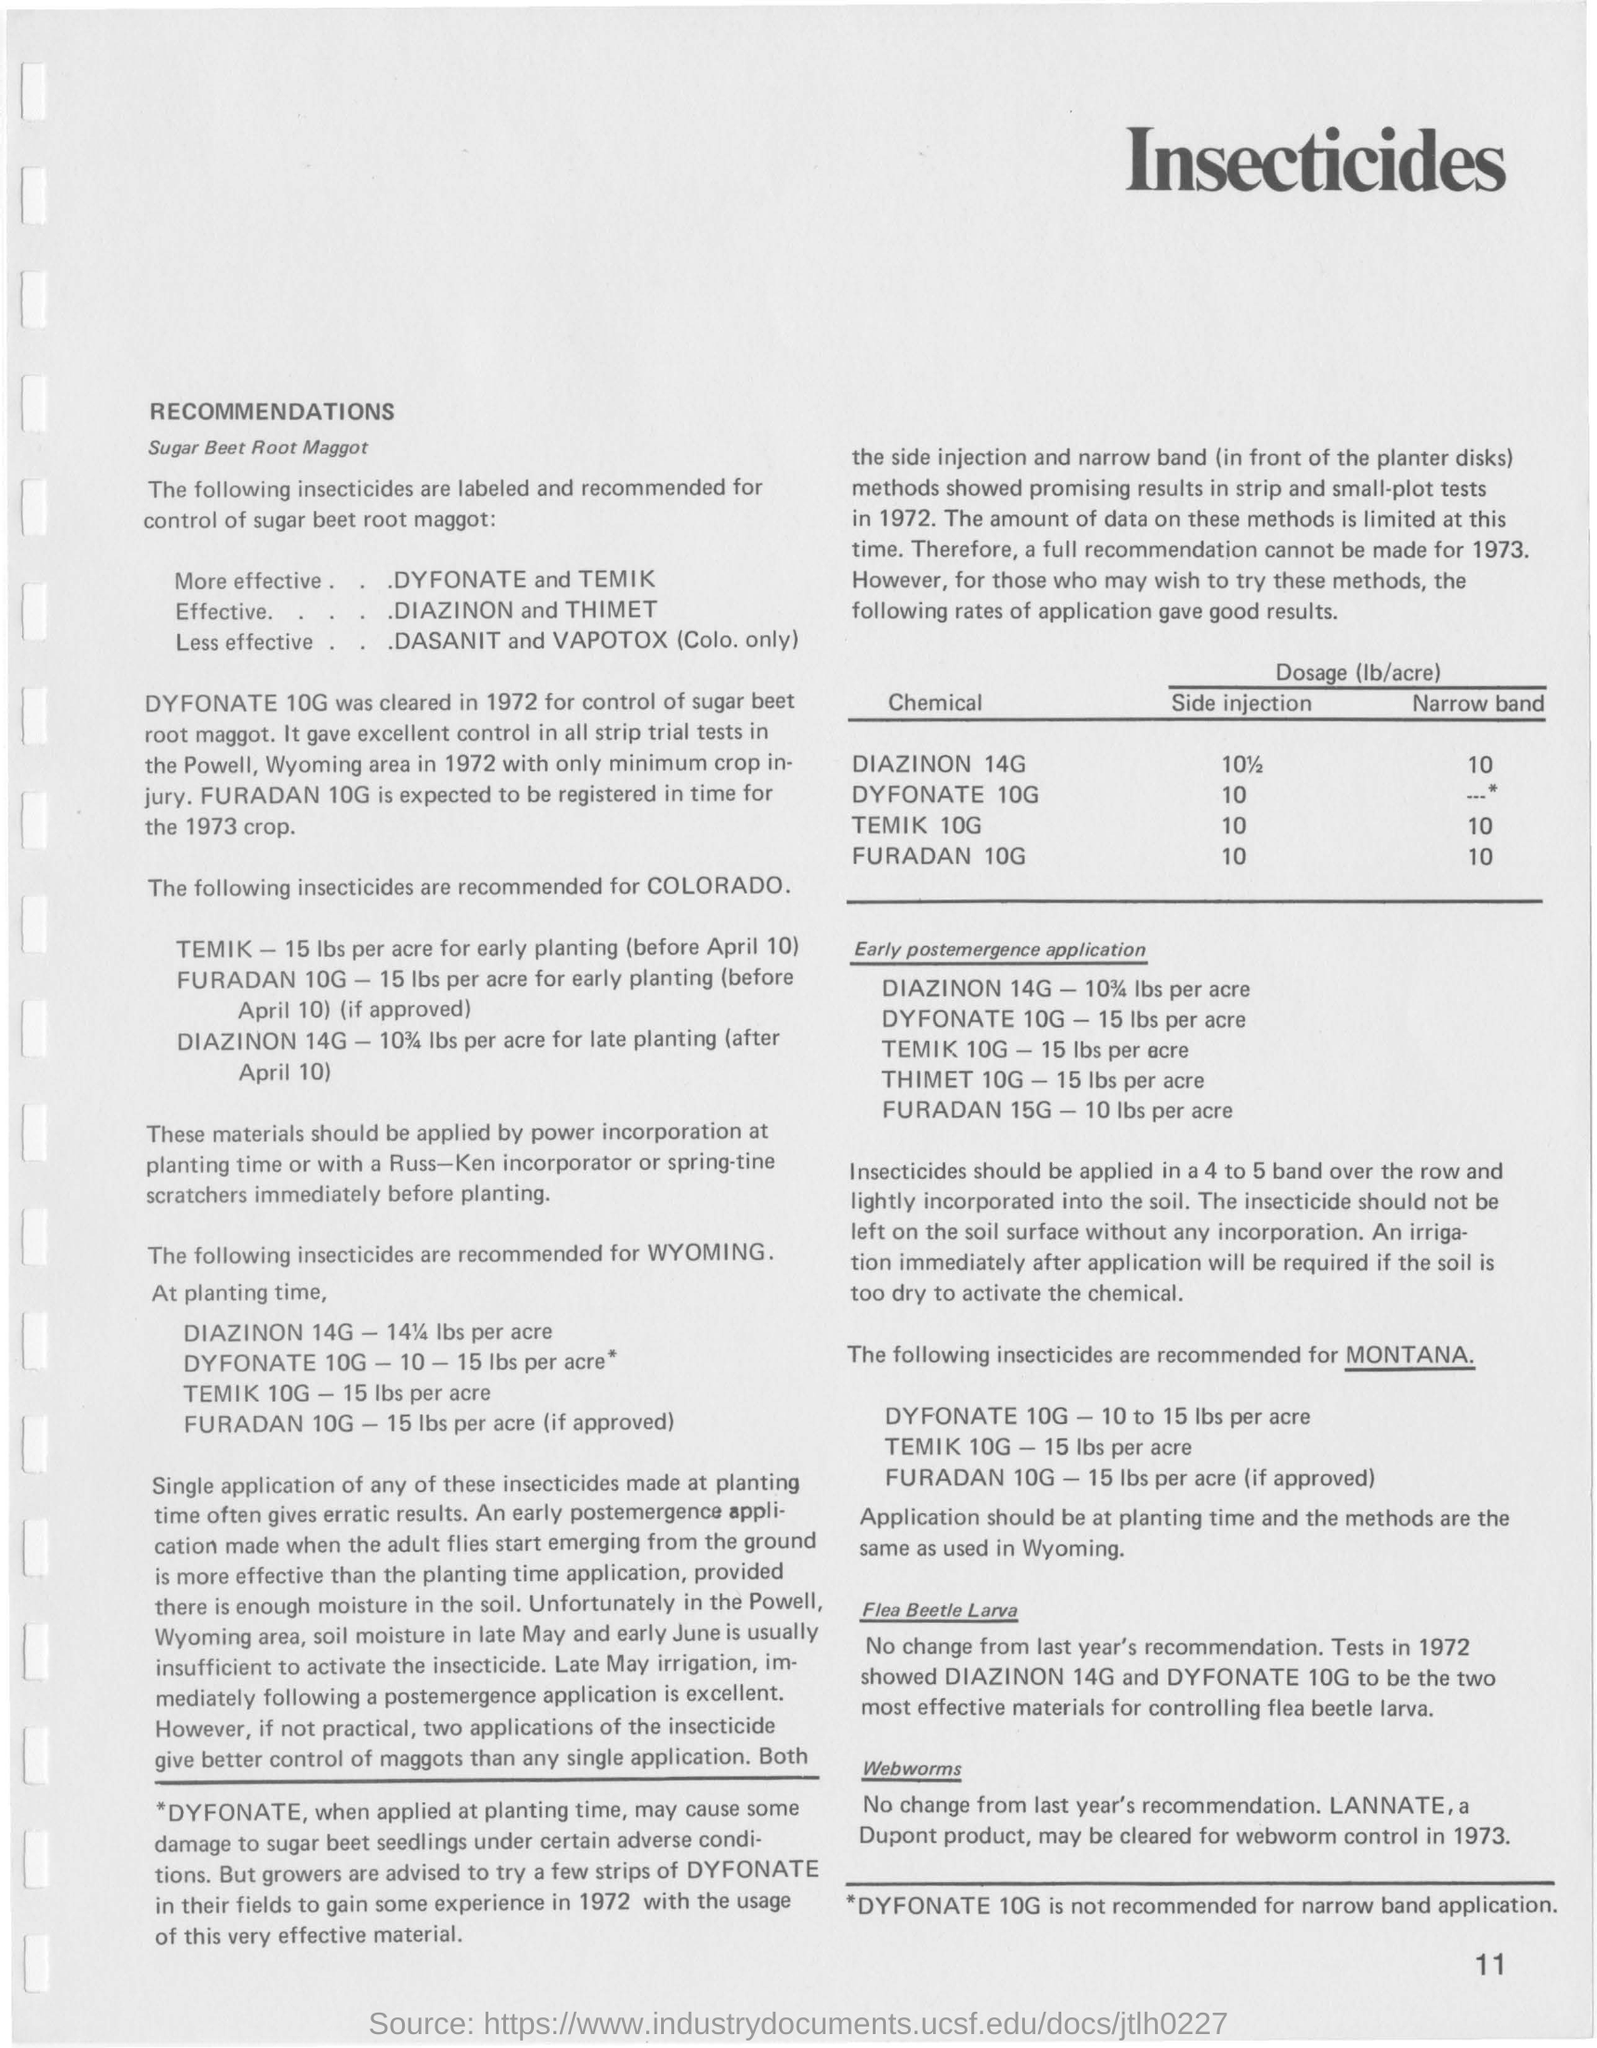Point out several critical features in this image. FURADAN 15G is applied at a dosage of 10 pounds per acre when used for early post-emergence treatment. The recommended dosage of Temik 10G for early post-emergence application is 15 lbs per acre. The effectiveness of Dyfonate and Temik as insecticides for controlling sugar beet root maggots has been evaluated. The dosage of Dyfonate 10G by the side injection method is [enter dosage here]. The insecticides DASANIT and VAPOTOX (only available in Colorado) are less effective in controlling sugar beet root maggot compared to other insecticides. 